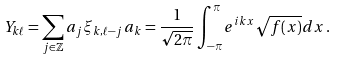<formula> <loc_0><loc_0><loc_500><loc_500>Y _ { k \ell } = \sum _ { j \in { \mathbb { Z } } } a _ { j } \xi _ { k , \ell - j } \, a _ { k } = \frac { 1 } { \sqrt { 2 \pi } } \int _ { - \pi } ^ { \pi } e ^ { { i } k x } \sqrt { f ( x ) } d x \, .</formula> 